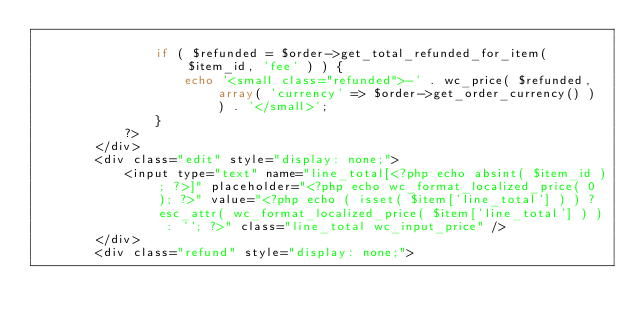Convert code to text. <code><loc_0><loc_0><loc_500><loc_500><_PHP_>
				if ( $refunded = $order->get_total_refunded_for_item( $item_id, 'fee' ) ) {
					echo '<small class="refunded">-' . wc_price( $refunded, array( 'currency' => $order->get_order_currency() ) ) . '</small>';
				}
			?>
		</div>
		<div class="edit" style="display: none;">
			<input type="text" name="line_total[<?php echo absint( $item_id ); ?>]" placeholder="<?php echo wc_format_localized_price( 0 ); ?>" value="<?php echo ( isset( $item['line_total'] ) ) ? esc_attr( wc_format_localized_price( $item['line_total'] ) ) : ''; ?>" class="line_total wc_input_price" />
		</div>
		<div class="refund" style="display: none;"></code> 